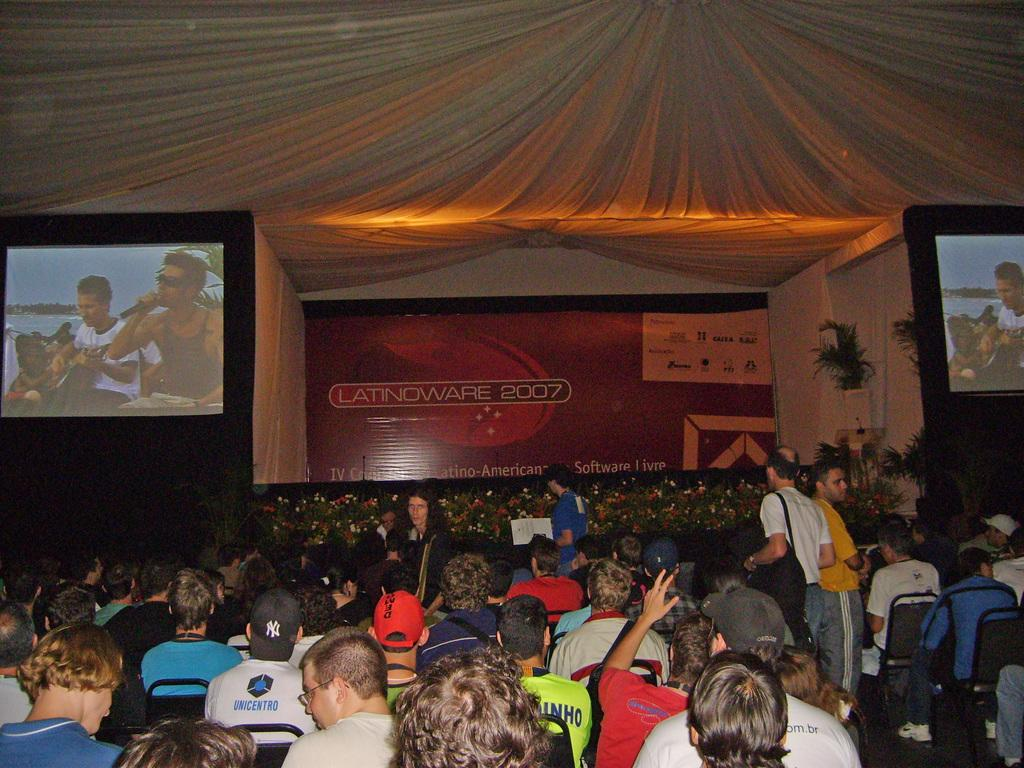How many people are in the image? There is a group of people in the image. What are the people in the image doing? Some people are sitting, while others are standing. What can be seen in the background of the image? There are two screens in the background of the image. What is the purpose of the banner visible in the image? The purpose of the banner is not specified in the provided facts. What type of boundary is depicted in the image? There is no boundary depicted in the image; it features a group of people with some sitting and others standing, as well as two screens and a banner in the background. 